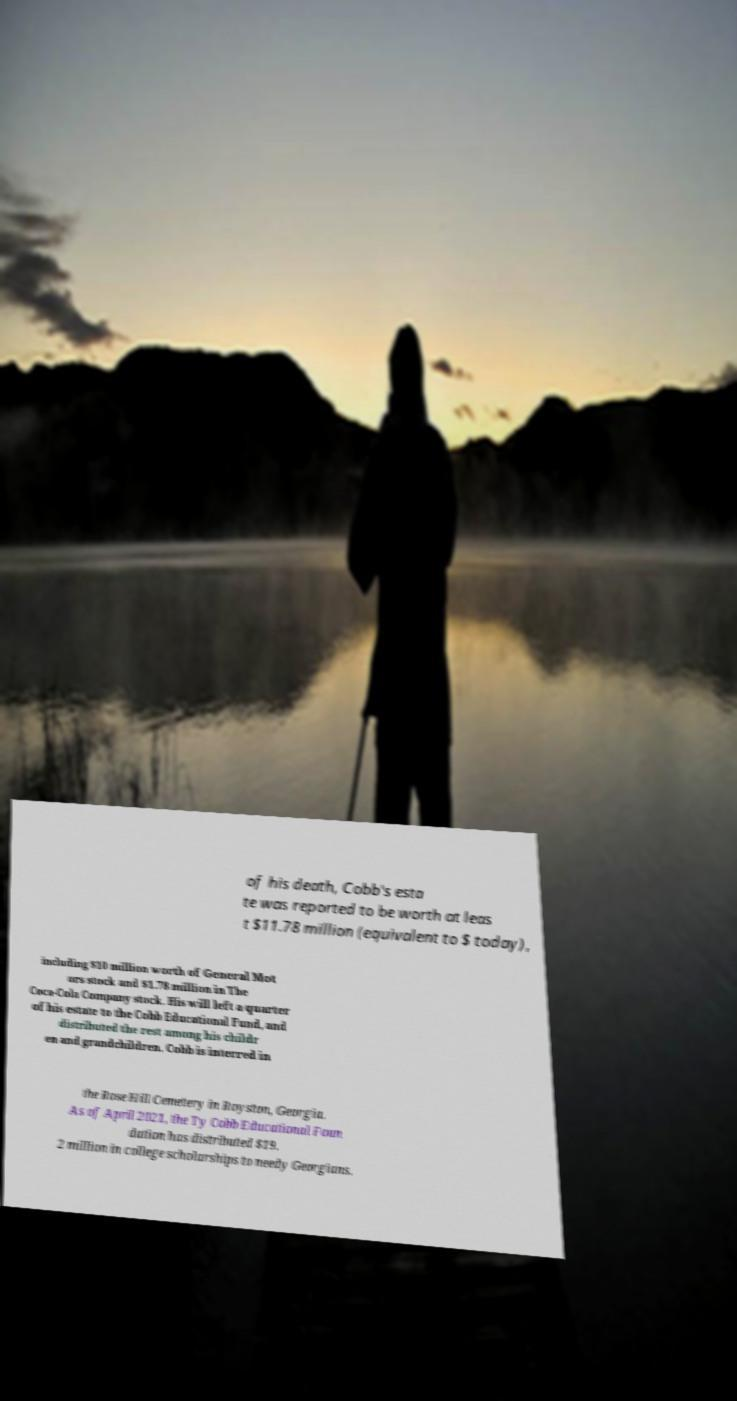For documentation purposes, I need the text within this image transcribed. Could you provide that? of his death, Cobb's esta te was reported to be worth at leas t $11.78 million (equivalent to $ today), including $10 million worth of General Mot ors stock and $1.78 million in The Coca-Cola Company stock. His will left a quarter of his estate to the Cobb Educational Fund, and distributed the rest among his childr en and grandchildren. Cobb is interred in the Rose Hill Cemetery in Royston, Georgia. As of April 2021, the Ty Cobb Educational Foun dation has distributed $19. 2 million in college scholarships to needy Georgians. 